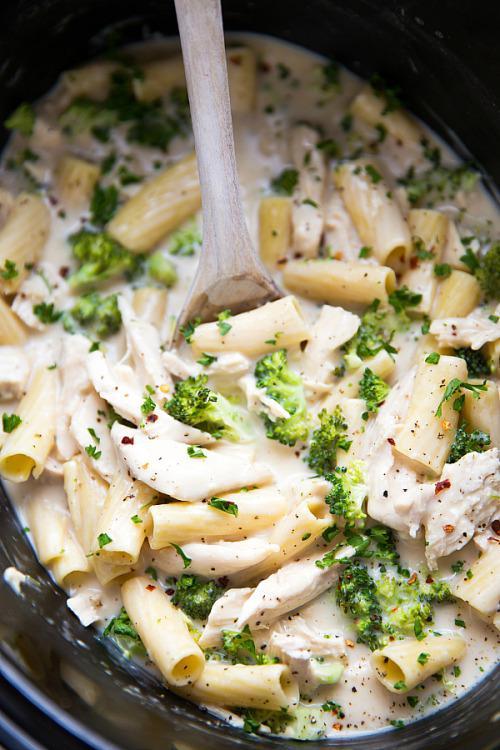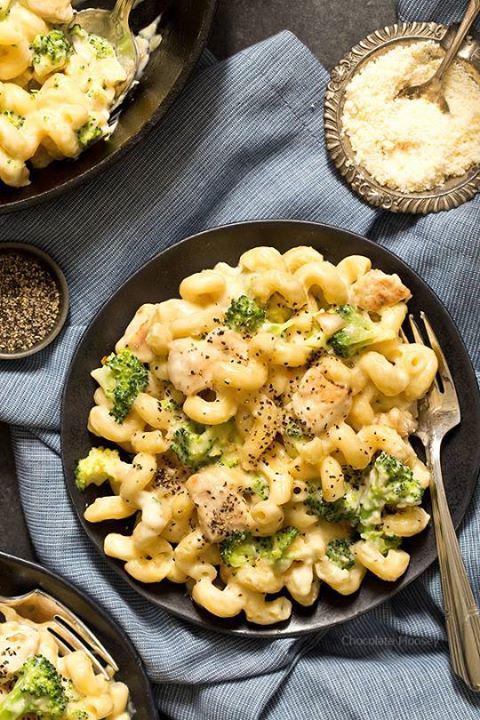The first image is the image on the left, the second image is the image on the right. Evaluate the accuracy of this statement regarding the images: "A fork is resting on a plate of pasta in one image.". Is it true? Answer yes or no. Yes. 